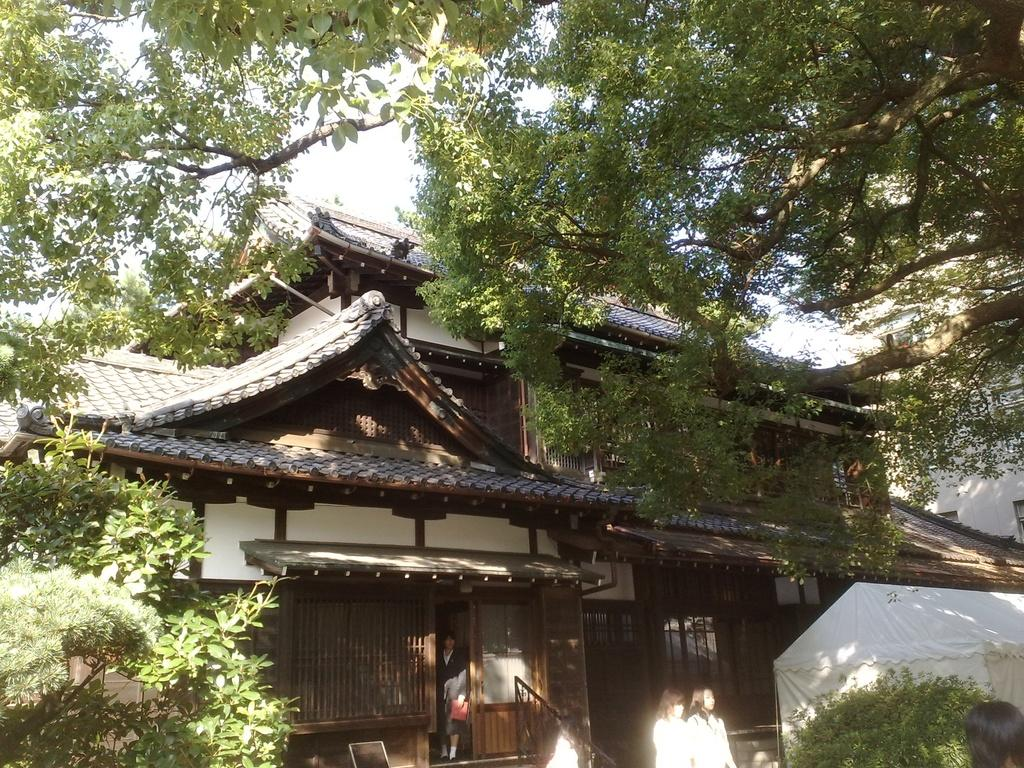What type of structure is visible in the image? There is a house in the image. What is located in front of the house? There are trees and persons in front of the house. What is visible at the top of the image? The sky is visible at the top of the image. What type of hat is the animal wearing in the image? There is no animal or hat present in the image. 